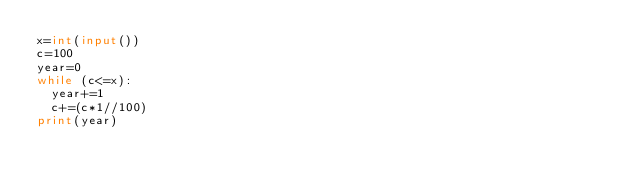Convert code to text. <code><loc_0><loc_0><loc_500><loc_500><_Python_>x=int(input())
c=100
year=0
while (c<=x):
  year+=1
  c+=(c*1//100)
print(year)</code> 